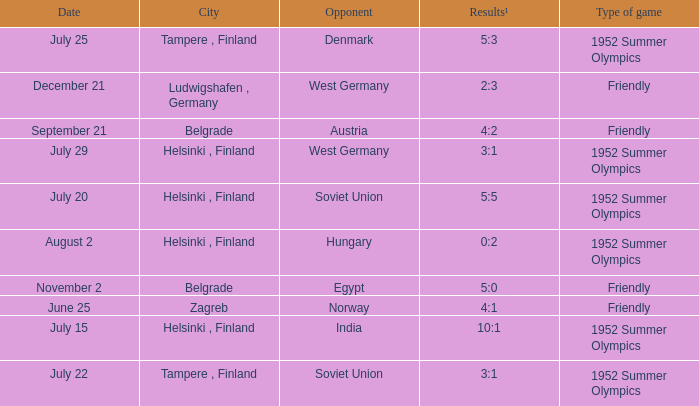What is the Results¹ that was a friendly game and played on June 25? 4:1. 